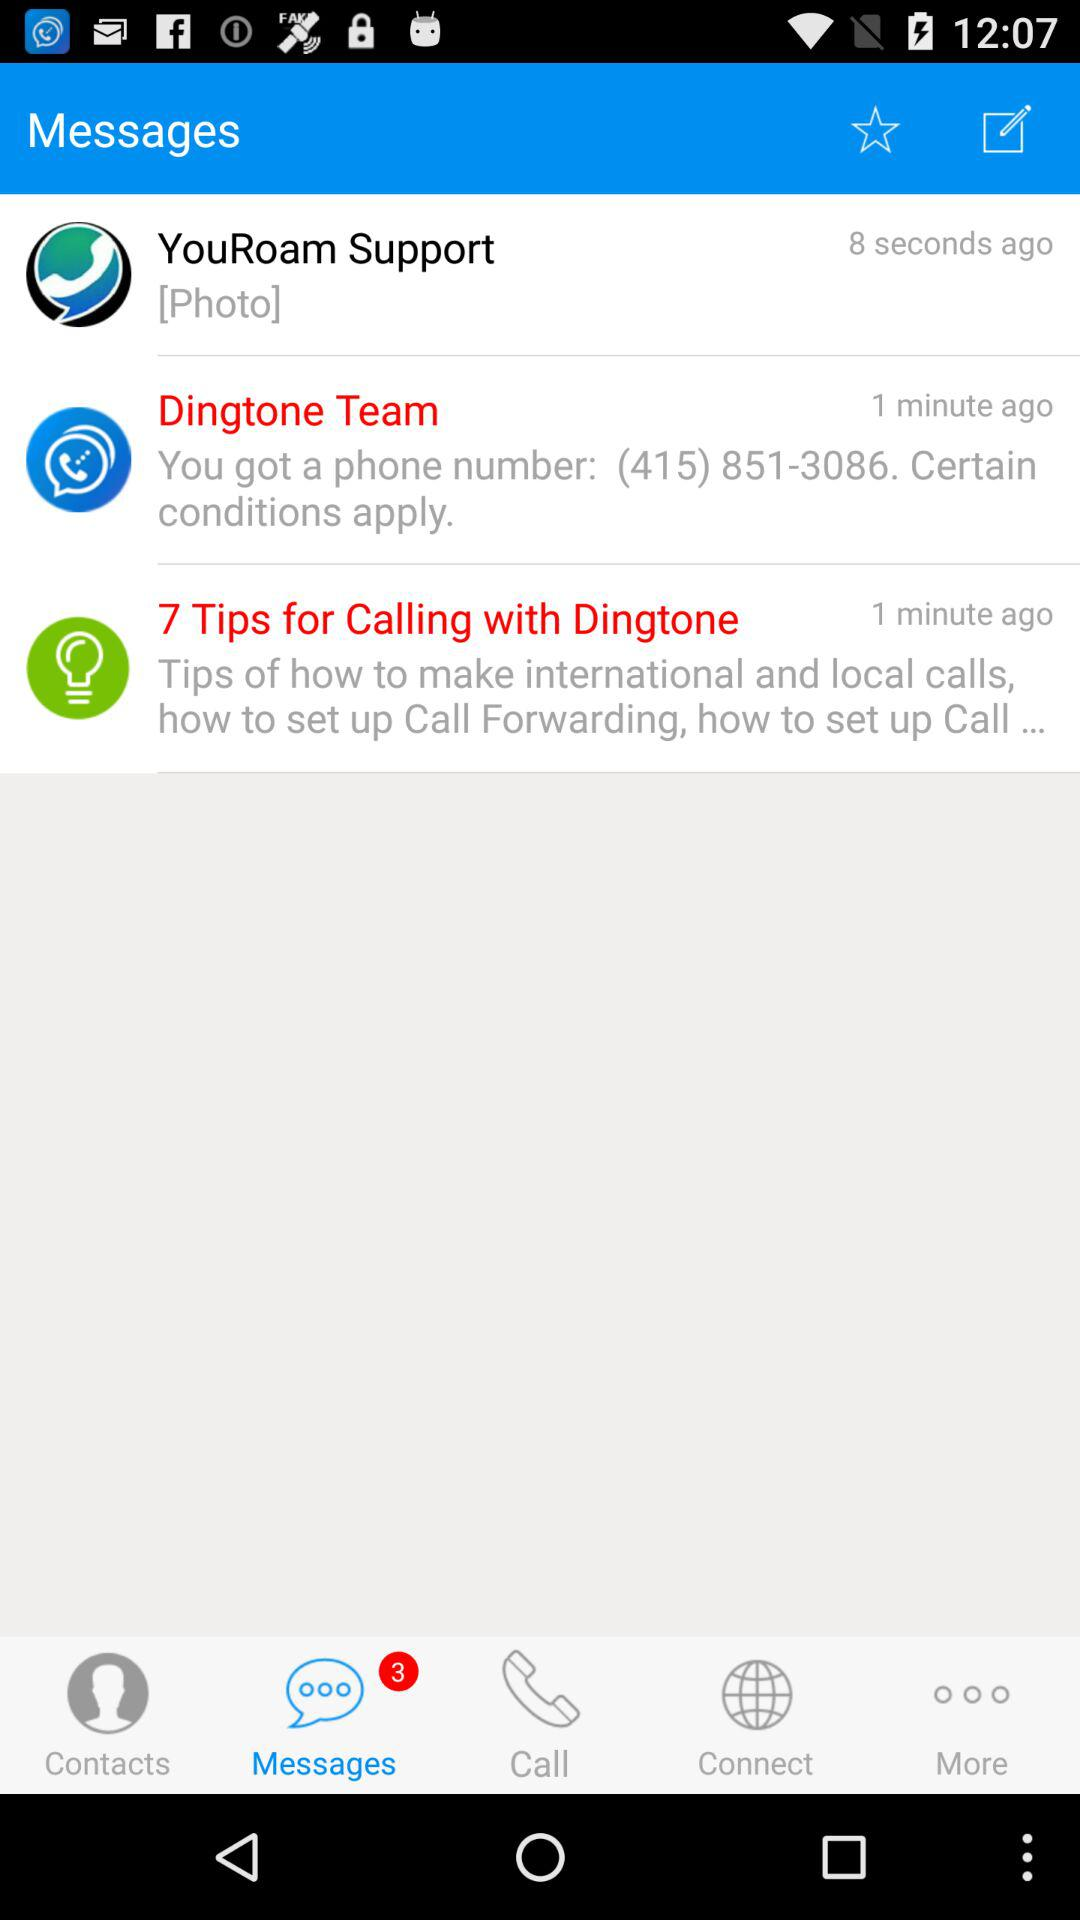How many unread messages are in the message box? There are 3 unread messages. 